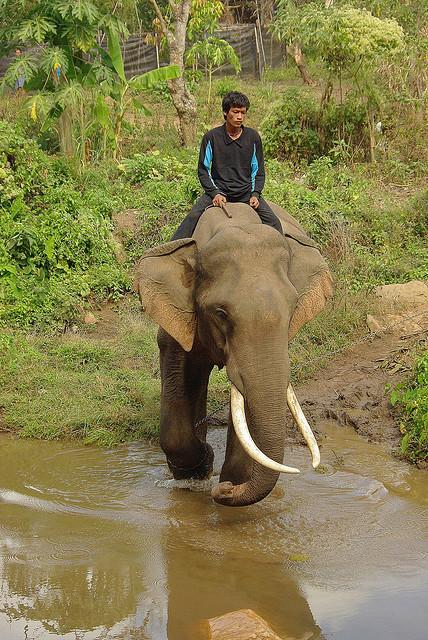What kind of animal is this?
Keep it brief. Elephant. Is the man wearing shorts?
Be succinct. No. Who is riding on the elephant?
Answer briefly. Man. How many people are riding the elephant?
Short answer required. 1. 